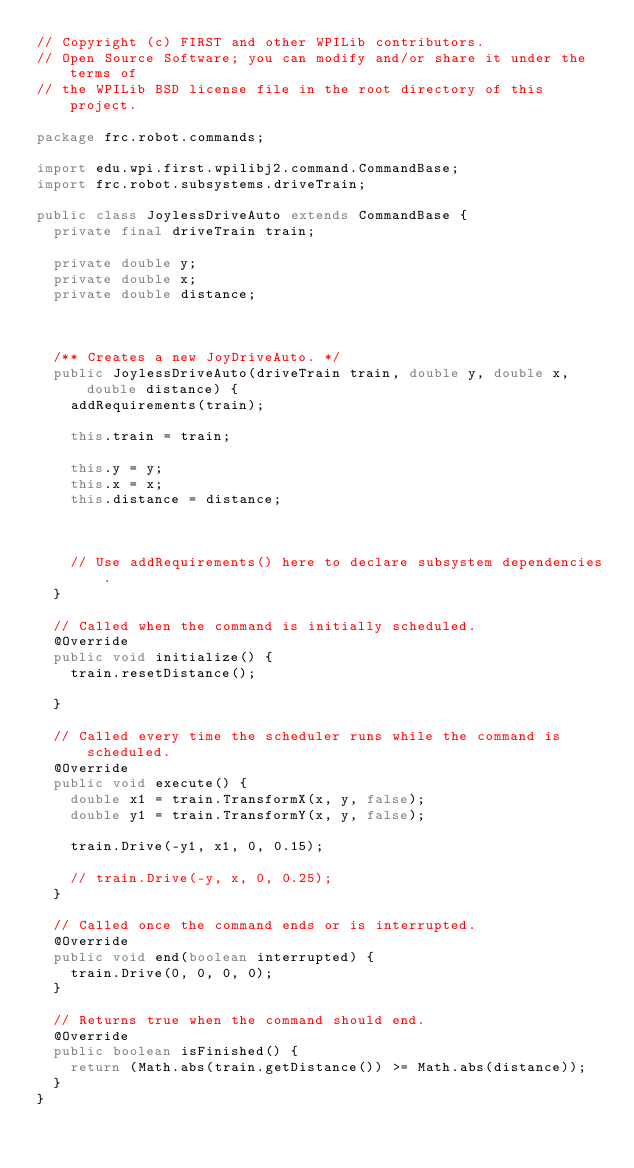Convert code to text. <code><loc_0><loc_0><loc_500><loc_500><_Java_>// Copyright (c) FIRST and other WPILib contributors.
// Open Source Software; you can modify and/or share it under the terms of
// the WPILib BSD license file in the root directory of this project.

package frc.robot.commands;

import edu.wpi.first.wpilibj2.command.CommandBase;
import frc.robot.subsystems.driveTrain;

public class JoylessDriveAuto extends CommandBase {
  private final driveTrain train;

  private double y;
  private double x;
  private double distance;



  /** Creates a new JoyDriveAuto. */
  public JoylessDriveAuto(driveTrain train, double y, double x, double distance) {
    addRequirements(train);

    this.train = train;

    this.y = y;
    this.x = x;
    this.distance = distance;
    

    
    // Use addRequirements() here to declare subsystem dependencies.
  }

  // Called when the command is initially scheduled.
  @Override
  public void initialize() {
    train.resetDistance();

  }

  // Called every time the scheduler runs while the command is scheduled.
  @Override
  public void execute() {
    double x1 = train.TransformX(x, y, false);
    double y1 = train.TransformY(x, y, false);

    train.Drive(-y1, x1, 0, 0.15);

    // train.Drive(-y, x, 0, 0.25);
  }

  // Called once the command ends or is interrupted.
  @Override
  public void end(boolean interrupted) {
    train.Drive(0, 0, 0, 0);
  }

  // Returns true when the command should end.
  @Override
  public boolean isFinished() {
    return (Math.abs(train.getDistance()) >= Math.abs(distance));
  }
}
</code> 